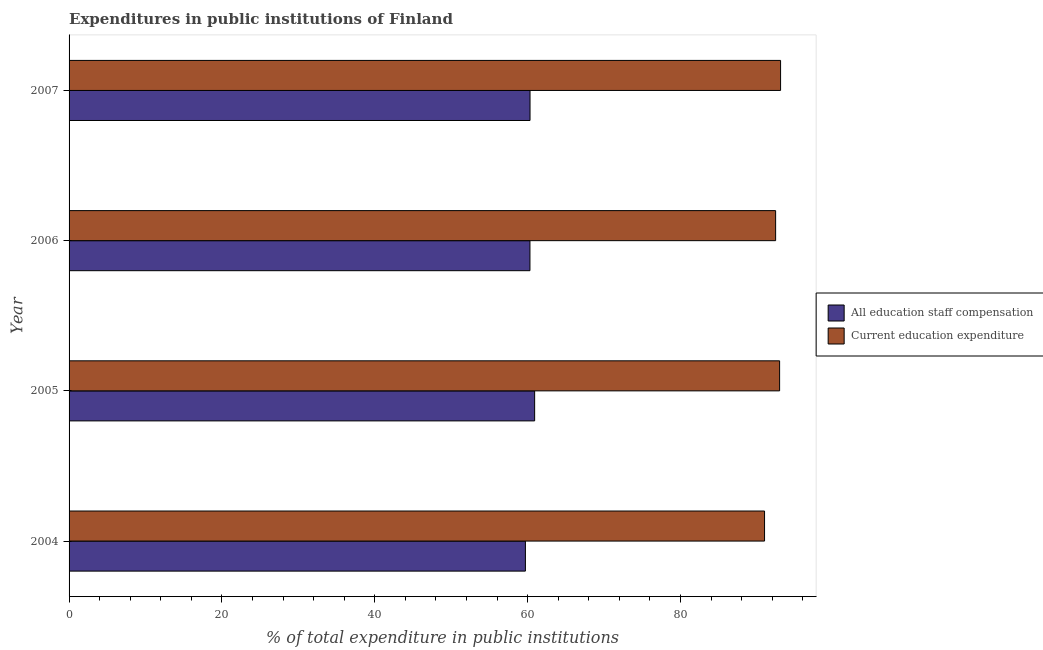How many different coloured bars are there?
Ensure brevity in your answer.  2. How many groups of bars are there?
Provide a short and direct response. 4. Are the number of bars on each tick of the Y-axis equal?
Your answer should be compact. Yes. How many bars are there on the 2nd tick from the top?
Offer a terse response. 2. What is the label of the 4th group of bars from the top?
Ensure brevity in your answer.  2004. In how many cases, is the number of bars for a given year not equal to the number of legend labels?
Offer a very short reply. 0. What is the expenditure in staff compensation in 2007?
Your response must be concise. 60.32. Across all years, what is the maximum expenditure in education?
Offer a very short reply. 93.1. Across all years, what is the minimum expenditure in staff compensation?
Make the answer very short. 59.71. In which year was the expenditure in education maximum?
Make the answer very short. 2007. In which year was the expenditure in education minimum?
Keep it short and to the point. 2004. What is the total expenditure in education in the graph?
Offer a very short reply. 369.53. What is the difference between the expenditure in education in 2004 and that in 2006?
Ensure brevity in your answer.  -1.45. What is the difference between the expenditure in education in 2004 and the expenditure in staff compensation in 2005?
Provide a succinct answer. 30.08. What is the average expenditure in staff compensation per year?
Keep it short and to the point. 60.31. In the year 2004, what is the difference between the expenditure in education and expenditure in staff compensation?
Your response must be concise. 31.29. In how many years, is the expenditure in staff compensation greater than 44 %?
Give a very brief answer. 4. What is the ratio of the expenditure in staff compensation in 2004 to that in 2007?
Your answer should be compact. 0.99. Is the expenditure in education in 2004 less than that in 2005?
Give a very brief answer. Yes. What is the difference between the highest and the second highest expenditure in education?
Offer a terse response. 0.13. What is the difference between the highest and the lowest expenditure in education?
Give a very brief answer. 2.1. In how many years, is the expenditure in education greater than the average expenditure in education taken over all years?
Ensure brevity in your answer.  3. What does the 1st bar from the top in 2005 represents?
Your response must be concise. Current education expenditure. What does the 2nd bar from the bottom in 2006 represents?
Keep it short and to the point. Current education expenditure. How many bars are there?
Offer a very short reply. 8. Are all the bars in the graph horizontal?
Provide a succinct answer. Yes. How many years are there in the graph?
Ensure brevity in your answer.  4. What is the difference between two consecutive major ticks on the X-axis?
Ensure brevity in your answer.  20. Are the values on the major ticks of X-axis written in scientific E-notation?
Provide a short and direct response. No. Does the graph contain any zero values?
Offer a very short reply. No. Does the graph contain grids?
Your answer should be very brief. No. Where does the legend appear in the graph?
Your answer should be very brief. Center right. What is the title of the graph?
Offer a very short reply. Expenditures in public institutions of Finland. Does "Age 15+" appear as one of the legend labels in the graph?
Provide a short and direct response. No. What is the label or title of the X-axis?
Provide a short and direct response. % of total expenditure in public institutions. What is the label or title of the Y-axis?
Keep it short and to the point. Year. What is the % of total expenditure in public institutions of All education staff compensation in 2004?
Your answer should be very brief. 59.71. What is the % of total expenditure in public institutions in Current education expenditure in 2004?
Your response must be concise. 91. What is the % of total expenditure in public institutions in All education staff compensation in 2005?
Give a very brief answer. 60.92. What is the % of total expenditure in public institutions in Current education expenditure in 2005?
Your answer should be compact. 92.98. What is the % of total expenditure in public institutions of All education staff compensation in 2006?
Offer a very short reply. 60.31. What is the % of total expenditure in public institutions in Current education expenditure in 2006?
Give a very brief answer. 92.45. What is the % of total expenditure in public institutions in All education staff compensation in 2007?
Make the answer very short. 60.32. What is the % of total expenditure in public institutions in Current education expenditure in 2007?
Provide a short and direct response. 93.1. Across all years, what is the maximum % of total expenditure in public institutions of All education staff compensation?
Keep it short and to the point. 60.92. Across all years, what is the maximum % of total expenditure in public institutions of Current education expenditure?
Give a very brief answer. 93.1. Across all years, what is the minimum % of total expenditure in public institutions in All education staff compensation?
Your answer should be compact. 59.71. Across all years, what is the minimum % of total expenditure in public institutions in Current education expenditure?
Offer a very short reply. 91. What is the total % of total expenditure in public institutions of All education staff compensation in the graph?
Keep it short and to the point. 241.26. What is the total % of total expenditure in public institutions in Current education expenditure in the graph?
Your answer should be compact. 369.53. What is the difference between the % of total expenditure in public institutions in All education staff compensation in 2004 and that in 2005?
Make the answer very short. -1.21. What is the difference between the % of total expenditure in public institutions in Current education expenditure in 2004 and that in 2005?
Your response must be concise. -1.97. What is the difference between the % of total expenditure in public institutions of All education staff compensation in 2004 and that in 2006?
Your answer should be very brief. -0.6. What is the difference between the % of total expenditure in public institutions of Current education expenditure in 2004 and that in 2006?
Provide a succinct answer. -1.45. What is the difference between the % of total expenditure in public institutions of All education staff compensation in 2004 and that in 2007?
Your answer should be very brief. -0.61. What is the difference between the % of total expenditure in public institutions of Current education expenditure in 2004 and that in 2007?
Keep it short and to the point. -2.1. What is the difference between the % of total expenditure in public institutions in All education staff compensation in 2005 and that in 2006?
Your response must be concise. 0.61. What is the difference between the % of total expenditure in public institutions in Current education expenditure in 2005 and that in 2006?
Make the answer very short. 0.52. What is the difference between the % of total expenditure in public institutions of All education staff compensation in 2005 and that in 2007?
Provide a short and direct response. 0.6. What is the difference between the % of total expenditure in public institutions in Current education expenditure in 2005 and that in 2007?
Your answer should be very brief. -0.13. What is the difference between the % of total expenditure in public institutions in All education staff compensation in 2006 and that in 2007?
Provide a succinct answer. -0.01. What is the difference between the % of total expenditure in public institutions in Current education expenditure in 2006 and that in 2007?
Your response must be concise. -0.65. What is the difference between the % of total expenditure in public institutions in All education staff compensation in 2004 and the % of total expenditure in public institutions in Current education expenditure in 2005?
Provide a short and direct response. -33.26. What is the difference between the % of total expenditure in public institutions in All education staff compensation in 2004 and the % of total expenditure in public institutions in Current education expenditure in 2006?
Your answer should be compact. -32.74. What is the difference between the % of total expenditure in public institutions of All education staff compensation in 2004 and the % of total expenditure in public institutions of Current education expenditure in 2007?
Give a very brief answer. -33.39. What is the difference between the % of total expenditure in public institutions in All education staff compensation in 2005 and the % of total expenditure in public institutions in Current education expenditure in 2006?
Ensure brevity in your answer.  -31.53. What is the difference between the % of total expenditure in public institutions of All education staff compensation in 2005 and the % of total expenditure in public institutions of Current education expenditure in 2007?
Your answer should be very brief. -32.18. What is the difference between the % of total expenditure in public institutions in All education staff compensation in 2006 and the % of total expenditure in public institutions in Current education expenditure in 2007?
Give a very brief answer. -32.79. What is the average % of total expenditure in public institutions of All education staff compensation per year?
Make the answer very short. 60.31. What is the average % of total expenditure in public institutions of Current education expenditure per year?
Provide a succinct answer. 92.38. In the year 2004, what is the difference between the % of total expenditure in public institutions of All education staff compensation and % of total expenditure in public institutions of Current education expenditure?
Offer a very short reply. -31.29. In the year 2005, what is the difference between the % of total expenditure in public institutions in All education staff compensation and % of total expenditure in public institutions in Current education expenditure?
Offer a very short reply. -32.05. In the year 2006, what is the difference between the % of total expenditure in public institutions in All education staff compensation and % of total expenditure in public institutions in Current education expenditure?
Your response must be concise. -32.15. In the year 2007, what is the difference between the % of total expenditure in public institutions in All education staff compensation and % of total expenditure in public institutions in Current education expenditure?
Keep it short and to the point. -32.78. What is the ratio of the % of total expenditure in public institutions of All education staff compensation in 2004 to that in 2005?
Offer a terse response. 0.98. What is the ratio of the % of total expenditure in public institutions in Current education expenditure in 2004 to that in 2005?
Offer a very short reply. 0.98. What is the ratio of the % of total expenditure in public institutions of Current education expenditure in 2004 to that in 2006?
Offer a terse response. 0.98. What is the ratio of the % of total expenditure in public institutions of All education staff compensation in 2004 to that in 2007?
Ensure brevity in your answer.  0.99. What is the ratio of the % of total expenditure in public institutions in Current education expenditure in 2004 to that in 2007?
Offer a terse response. 0.98. What is the ratio of the % of total expenditure in public institutions in All education staff compensation in 2005 to that in 2006?
Offer a very short reply. 1.01. What is the ratio of the % of total expenditure in public institutions in Current education expenditure in 2005 to that in 2006?
Give a very brief answer. 1.01. What is the ratio of the % of total expenditure in public institutions in All education staff compensation in 2005 to that in 2007?
Provide a succinct answer. 1.01. What is the ratio of the % of total expenditure in public institutions of All education staff compensation in 2006 to that in 2007?
Provide a succinct answer. 1. What is the ratio of the % of total expenditure in public institutions in Current education expenditure in 2006 to that in 2007?
Keep it short and to the point. 0.99. What is the difference between the highest and the second highest % of total expenditure in public institutions of All education staff compensation?
Your answer should be compact. 0.6. What is the difference between the highest and the second highest % of total expenditure in public institutions of Current education expenditure?
Provide a short and direct response. 0.13. What is the difference between the highest and the lowest % of total expenditure in public institutions in All education staff compensation?
Ensure brevity in your answer.  1.21. What is the difference between the highest and the lowest % of total expenditure in public institutions in Current education expenditure?
Provide a succinct answer. 2.1. 